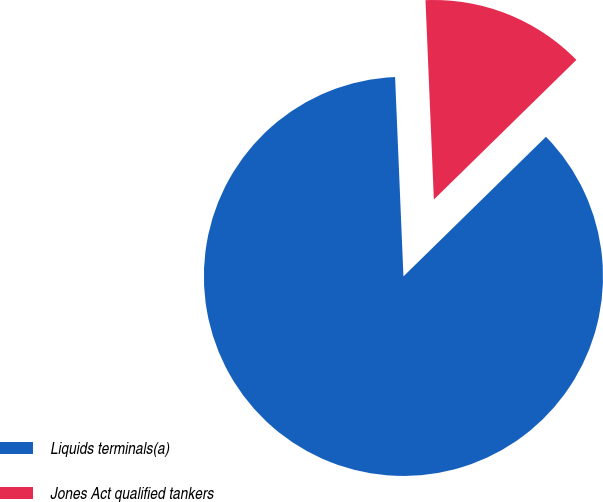Convert chart. <chart><loc_0><loc_0><loc_500><loc_500><pie_chart><fcel>Liquids terminals(a)<fcel>Jones Act qualified tankers<nl><fcel>86.67%<fcel>13.33%<nl></chart> 